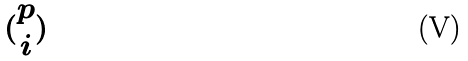Convert formula to latex. <formula><loc_0><loc_0><loc_500><loc_500>( \begin{matrix} p \\ i \end{matrix} )</formula> 